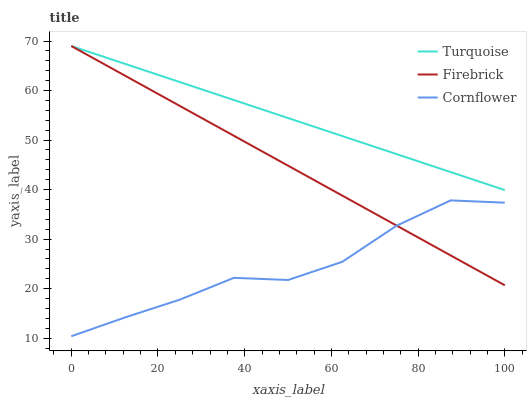Does Cornflower have the minimum area under the curve?
Answer yes or no. Yes. Does Turquoise have the maximum area under the curve?
Answer yes or no. Yes. Does Firebrick have the minimum area under the curve?
Answer yes or no. No. Does Firebrick have the maximum area under the curve?
Answer yes or no. No. Is Firebrick the smoothest?
Answer yes or no. Yes. Is Cornflower the roughest?
Answer yes or no. Yes. Is Turquoise the smoothest?
Answer yes or no. No. Is Turquoise the roughest?
Answer yes or no. No. Does Cornflower have the lowest value?
Answer yes or no. Yes. Does Firebrick have the lowest value?
Answer yes or no. No. Does Firebrick have the highest value?
Answer yes or no. Yes. Is Cornflower less than Turquoise?
Answer yes or no. Yes. Is Turquoise greater than Cornflower?
Answer yes or no. Yes. Does Firebrick intersect Cornflower?
Answer yes or no. Yes. Is Firebrick less than Cornflower?
Answer yes or no. No. Is Firebrick greater than Cornflower?
Answer yes or no. No. Does Cornflower intersect Turquoise?
Answer yes or no. No. 